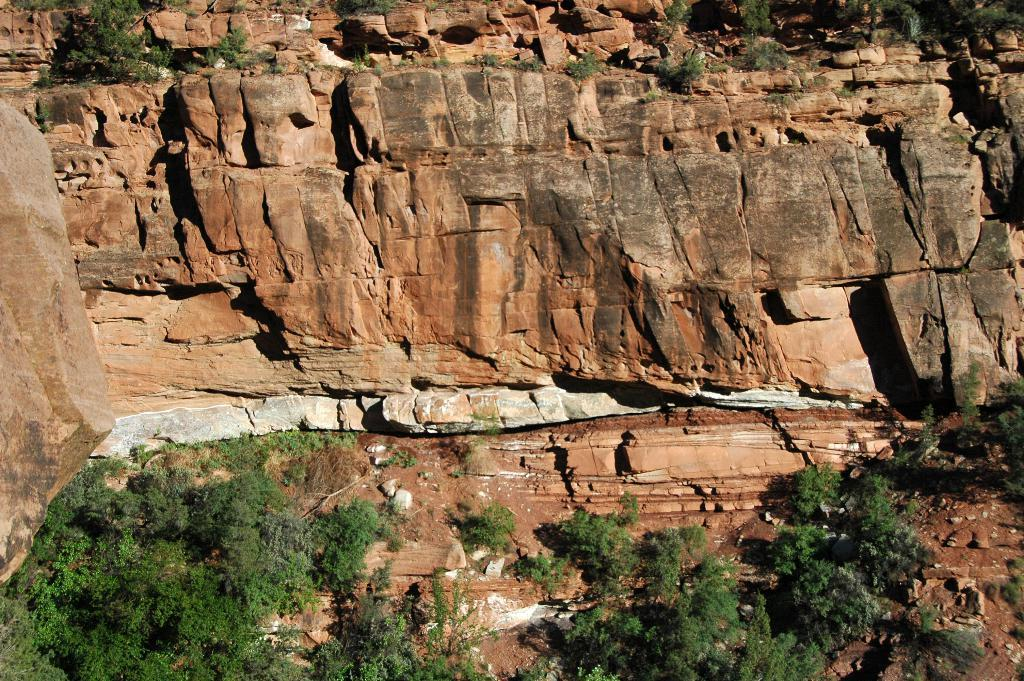What type of natural landscape is depicted in the image? The image contains mountains. What can be seen in the foreground of the image? There are rocks in the front of the image. What type of vegetation is present at the bottom of the image? There are trees at the bottom of the image. What song are the girls singing while standing near the bee in the image? There are no girls or bees present in the image; it features mountains, rocks, and trees. 